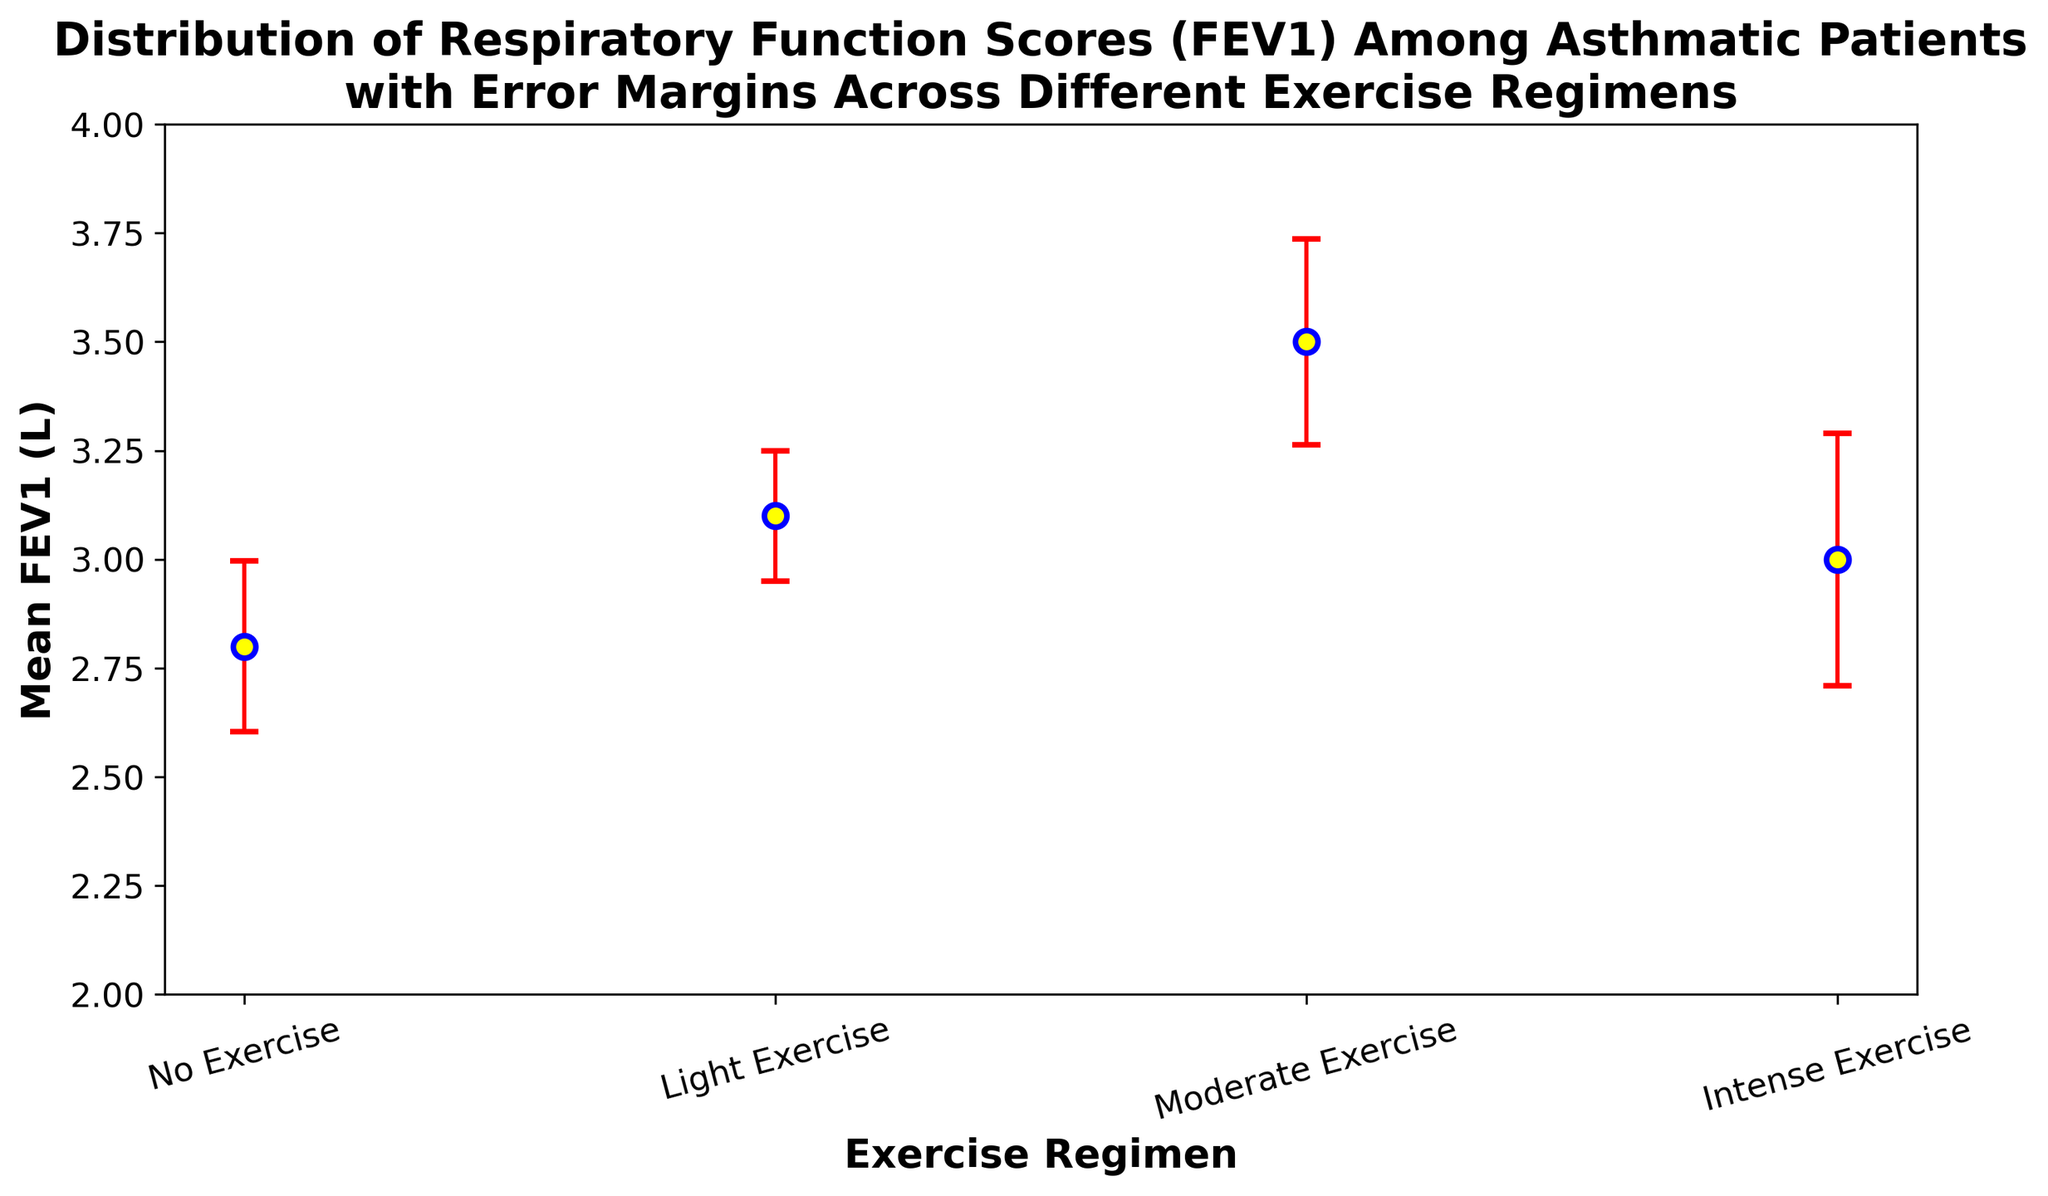Which exercise regimen shows the highest mean FEV1? The figure indicates the mean FEV1 value for each exercise regimen. By comparing the means, Moderate Exercise has the highest mean FEV1.
Answer: Moderate Exercise What is the difference between the mean FEV1 values of Moderate Exercise and Intense Exercise regimens? The mean FEV1 for Moderate Exercise is the highest, while for Intense Exercise, it is lower. By calculating the difference: 3.5 (Moderate) - 3.0 (Intense) = 0.5
Answer: 0.5 Which exercise regimen has the smallest error margin (standard error) in FEV1? The figure shows the error margins for each exercise regimen with error bars. By comparing the error margins, Light Exercise has the smallest standard error.
Answer: Light Exercise How much lower is the mean FEV1 for the No Exercise regimen compared to the Light Exercise regimen? From the figure, we find the mean FEV1 for No Exercise and Light Exercise, then subtract: 3.1 (Light Exercise) - 2.8 (No Exercise) = 0.3
Answer: 0.3 Order the exercise regimens from highest to lowest mean FEV1. By comparing the mean FEV1 values in the figure, the order is: Moderate Exercise > Light Exercise > Intense Exercise > No Exercise.
Answer: Moderate Exercise, Light Exercise, Intense Exercise, No Exercise What is the average mean FEV1 across all exercise regimens? The mean FEV1 values are given for each exercise regimen. Summing those means and dividing by the number of regimens: (3.1 + 2.8 + 3.5 + 3.0)/4 = 3.1
Answer: 3.1 Which exercise regimen shows the highest variability in FEV1 (as indicated by the size of the error bar)? The size of the error bar represents the variability. Intense Exercise has the largest error bar, indicating the highest variability.
Answer: Intense Exercise Is there any exercise regimen where the mean FEV1 is equal to 3.0? From the figure, we see that Intense Exercise has a mean FEV1 of 3.0.
Answer: Intense Exercise 